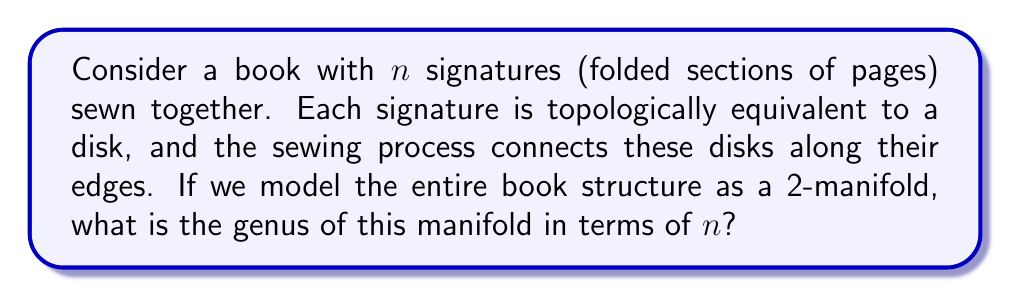Give your solution to this math problem. To solve this problem, we need to consider the topological properties of the book structure:

1. Each signature is topologically equivalent to a disk, which is a 2-manifold with boundary.

2. The sewing process connects these disks along their edges, effectively "gluing" them together.

3. The resulting structure is a connected 2-manifold without boundary.

4. To determine the genus, we need to calculate the Euler characteristic $\chi$ of the manifold.

5. The Euler characteristic is related to the genus $g$ by the formula:

   $$\chi = 2 - 2g$$

6. To calculate $\chi$, we need to consider the vertices (V), edges (E), and faces (F) of the manifold:

   $$\chi = V - E + F$$

7. In our book structure:
   - There are $n$ faces (one for each signature)
   - The number of edges is equal to the number of connections between signatures, which is $n-1$
   - There are no vertices in this structure

8. Therefore, the Euler characteristic is:

   $$\chi = 0 - (n-1) + n = 1$$

9. Substituting this into the genus formula:

   $$1 = 2 - 2g$$
   $$2g = 1$$
   $$g = \frac{1}{2}$$

10. Since the genus must be a non-negative integer, we round up to the nearest whole number.
Answer: The genus of the 2-manifold representing the book structure is $1$, regardless of the number of signatures $n$ (assuming $n \geq 2$). 